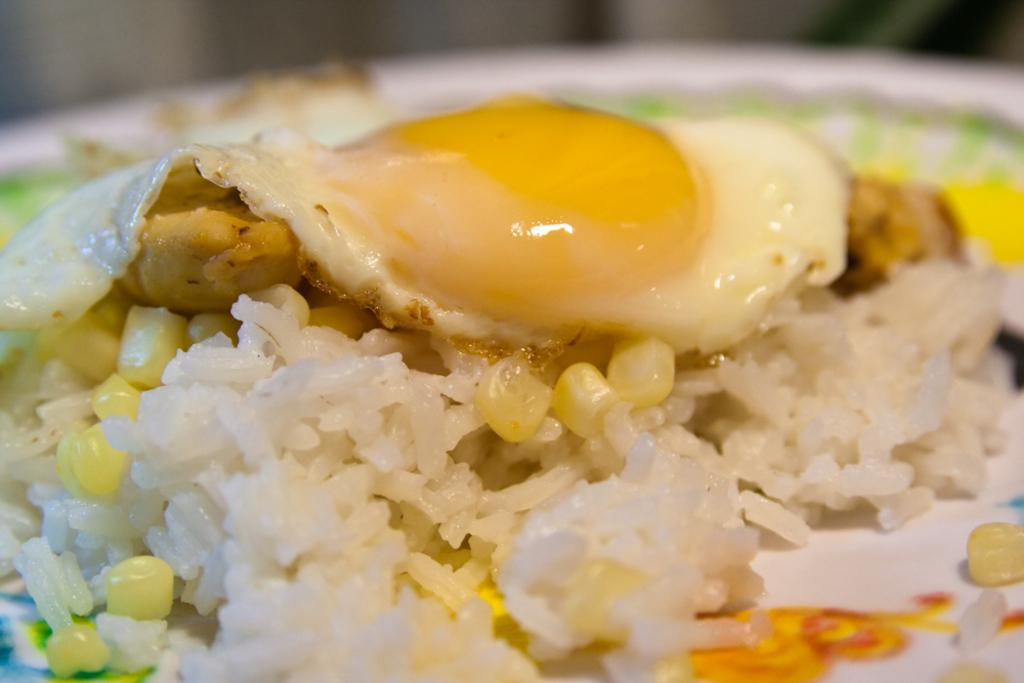What type of food is visible in the image? There is a half-boiled omelet in the image. What is the omelet placed on? The omelet is present on rice. How many eyes can be seen on the clover in the image? There is no clover or eyes present in the image; it features a half-boiled omelet on rice. What shape is the omelet in the image? The provided facts do not specify the shape of the omelet, so we cannot definitively answer that question. 